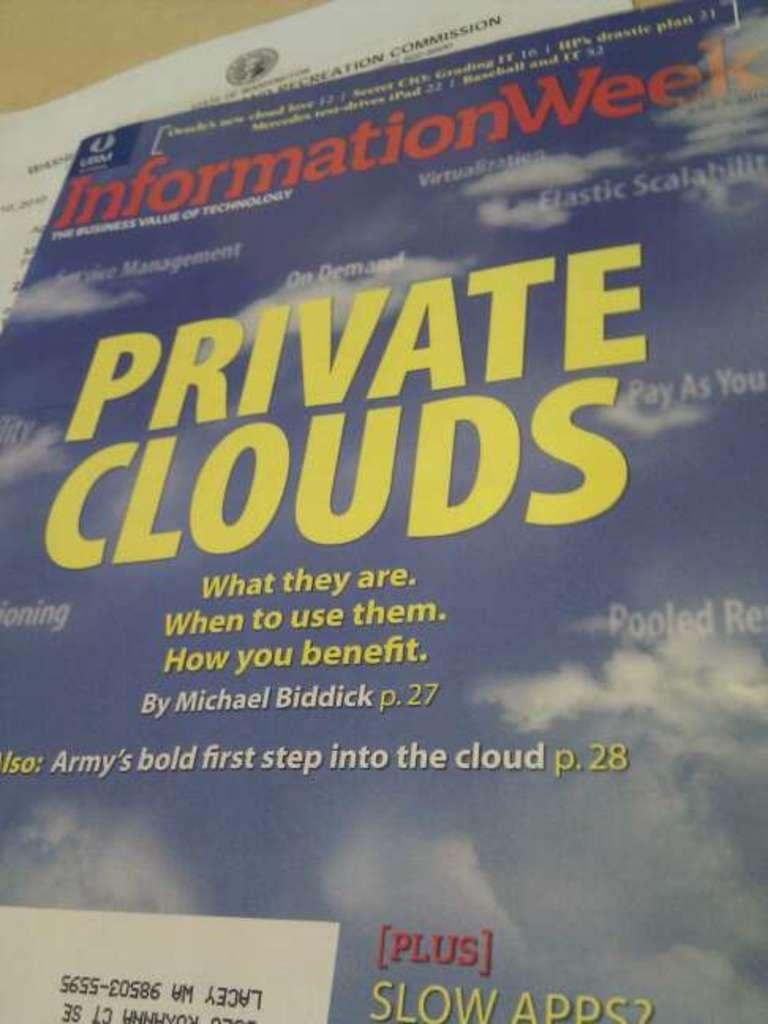Provide a one-sentence caption for the provided image. An information poster with private clouds written on it. 